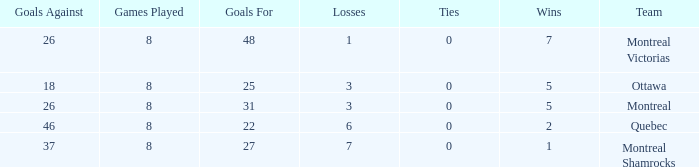For teams with more than 0 ties and goals against of 37, how many wins were tallied? None. 